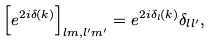Convert formula to latex. <formula><loc_0><loc_0><loc_500><loc_500>\left [ e ^ { 2 i \delta ( k ) } \right ] _ { l m , l ^ { \prime } m ^ { \prime } } = e ^ { 2 i \delta _ { l } ( k ) } \delta _ { l l ^ { \prime } } ,</formula> 